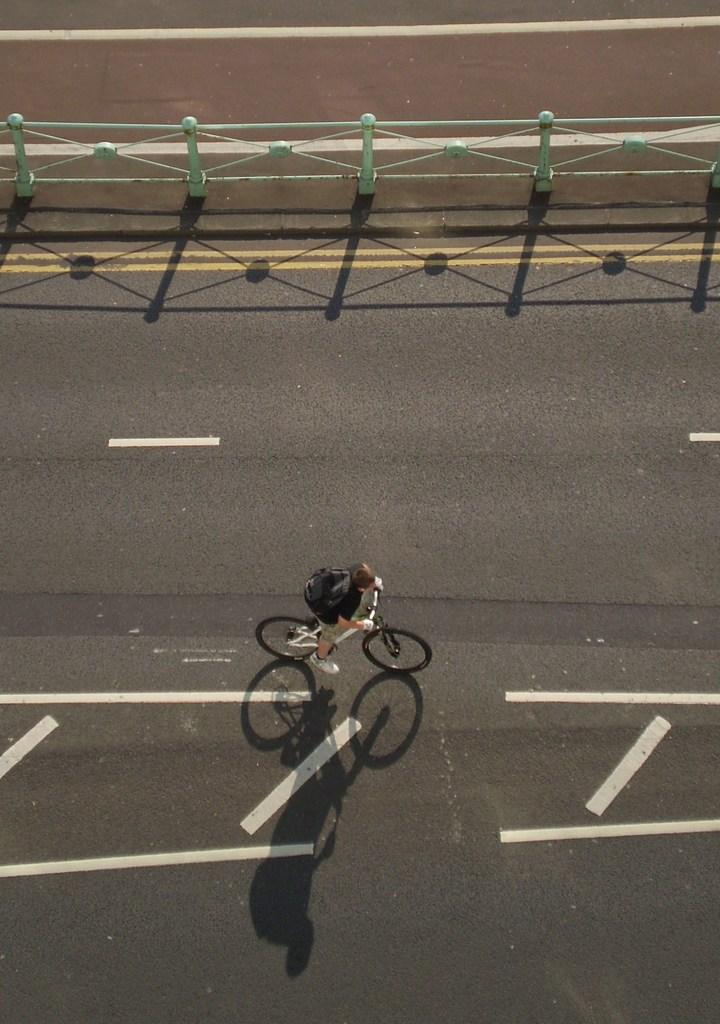What is the man in the image doing? The man is riding a bicycle in the image. What is the man wearing while riding the bicycle? The man is wearing a bag and white color shoes. What can be seen in the background of the image? The image shows a road and an iron fence at the top. What type of silk fabric is draped over the man's bicycle in the image? There is no silk fabric present in the image; the man is simply riding a bicycle. 